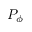<formula> <loc_0><loc_0><loc_500><loc_500>P _ { \phi }</formula> 